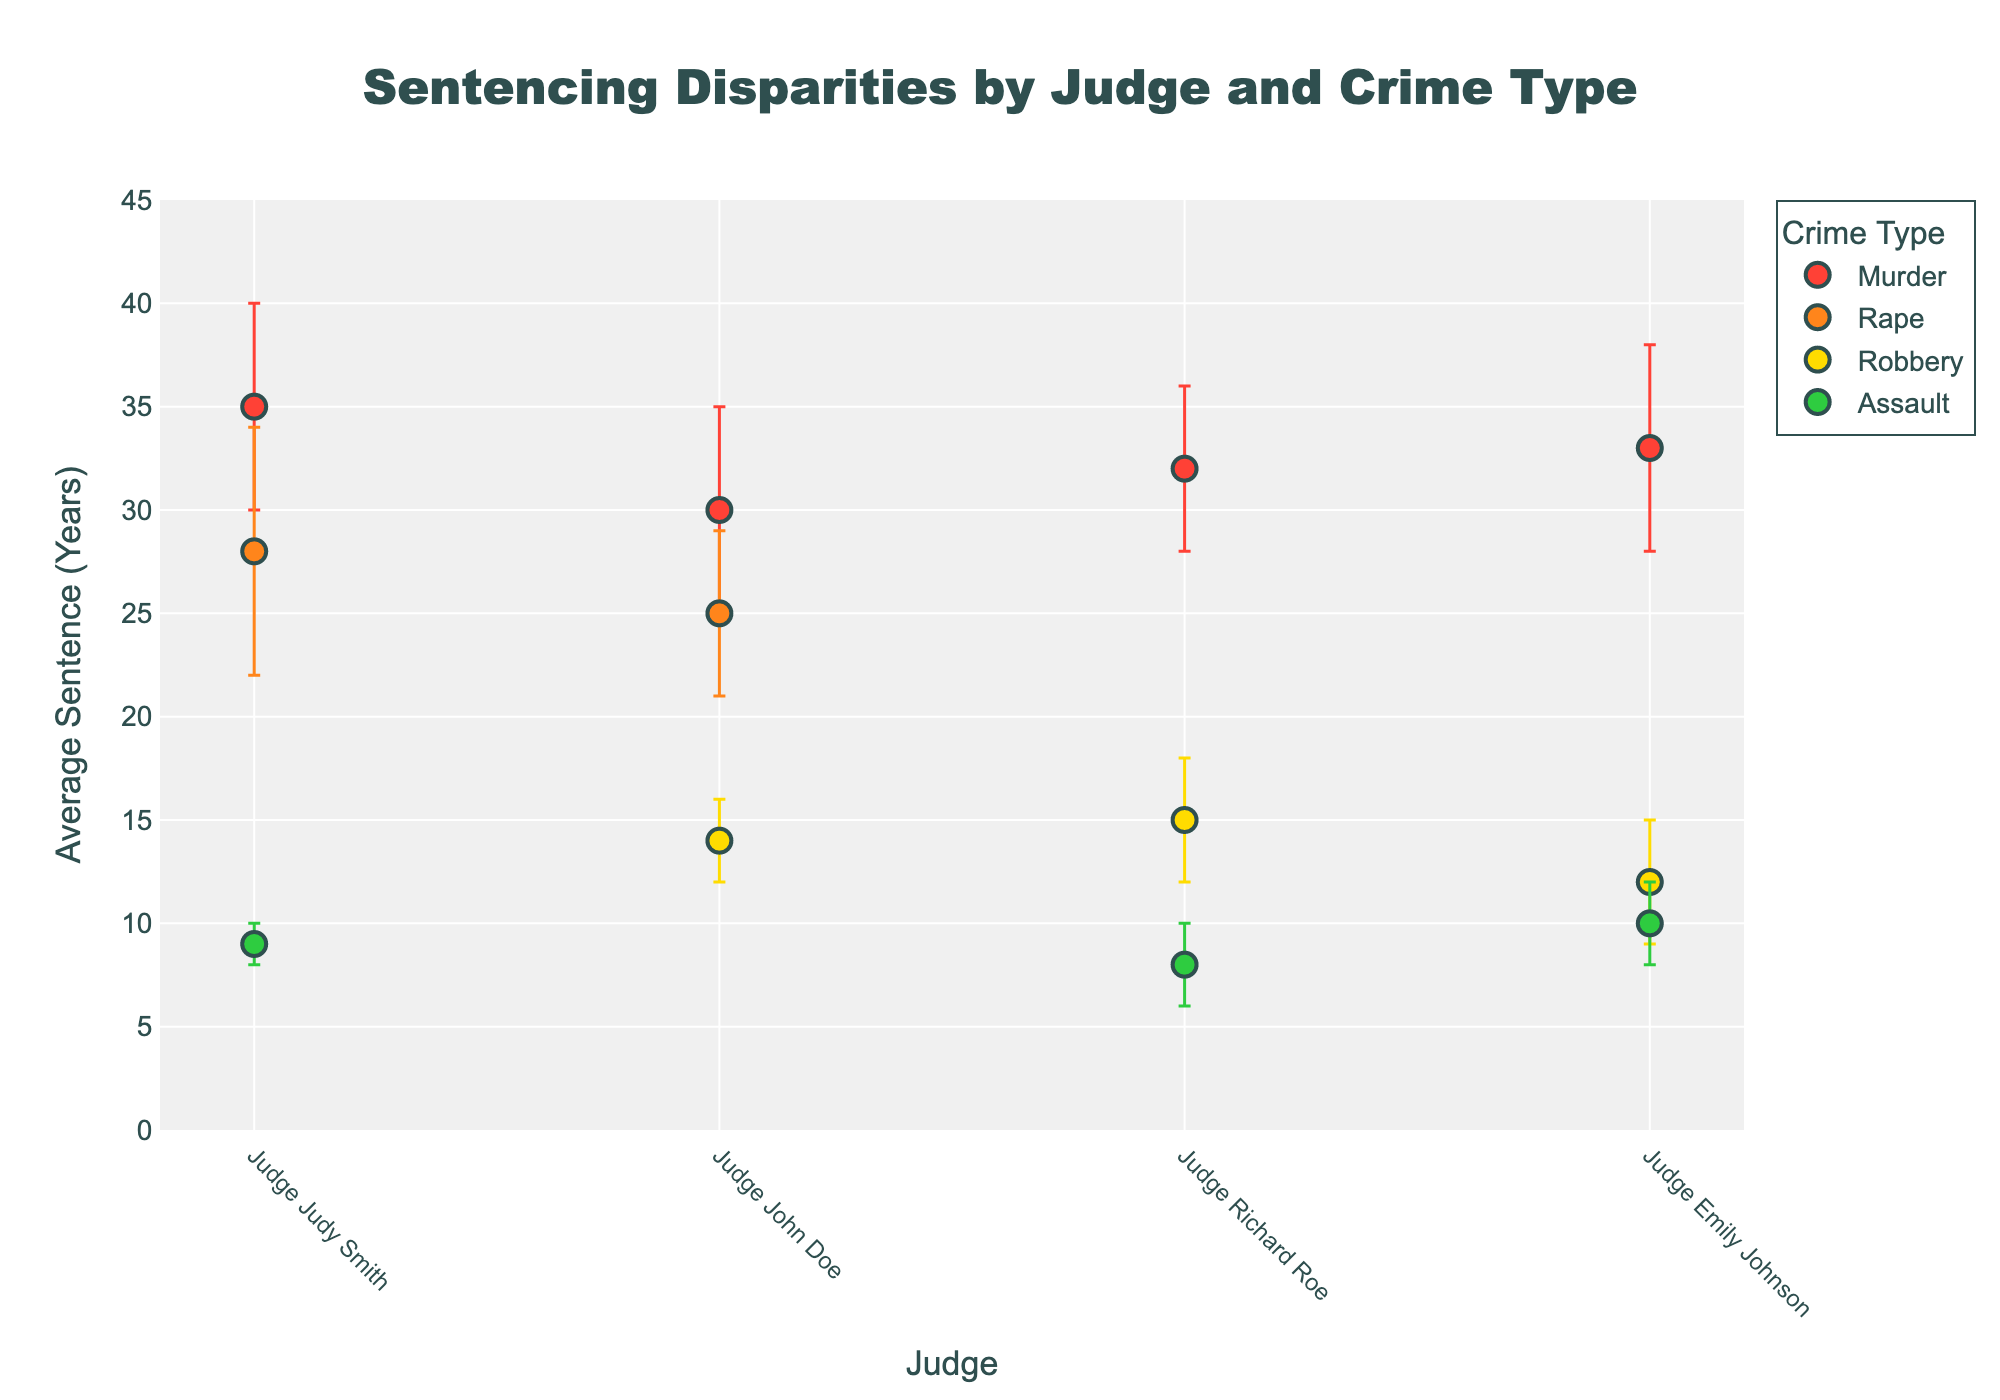Which judge has the highest average sentence for murder? We look at the average sentences for murder and find the judge with the highest value. Judge Emily Johnson has an average sentence of 33 years for murder.
Answer: Judge Emily Johnson What is the range of average sentences for assault cases? Identify the lowest and highest average sentences for assault, then calculate the range. Judge Emily Johnson has the highest at 10 years, and Judge Richard Roe has the lowest at 8 years. The range is 10 - 8 = 2 years.
Answer: 2 years Which crime type has the most consistent sentences across judges, considering the margin of error? Consistency can be inferred from the smallest margins of error. Assault has the smallest margins of error (2 and 1 years), indicating high consistency.
Answer: Assault How does Judge Judy Smith's average sentence for rape compare to Judge John Doe's? Look at the average sentences for rape from these judges: Judge Judy Smith's average is 28 years and Judge John Doe's is 25 years. Compare these two values. Judge Judy Smith gives longer average sentences.
Answer: Judge Judy Smith gives longer sentences What is the total average sentence given by Judge Richard Roe across all crime types? Sum the average sentences by Judge Richard Roe for all crime types: 32 (Murder) + 15 (Robbery) + 8 (Assault) = 55 years.
Answer: 55 years Which judge shows the highest variability in sentencing, and for what crime type? Variability can be assessed by looking at the margin of error. Judge Judy Smith’s margin of error for rape is the highest at 6 years.
Answer: Judge Judy Smith for rape What is the overall trend in sentences for murder among the judges? Average sentences for murder are 35, 30, 32, and 33 years. This shows that all judges give relatively high sentences for murder, all above 30 years.
Answer: High sentences above 30 years across all judges How does the average sentence for robbery given by Judge John Doe compare to the average sentence for robbery given by Judge Richard Roe? Compare the average sentences for robbery for both judges: Judge John Doe gives 14 years and Judge Richard Roe gives 15 years. Judge Richard Roe gives longer sentences.
Answer: Judge Richard Roe gives longer sentences What is the average margin of error across all crime types judged by Judge Emily Johnson? Identify the margin of error for each crime type handled by Judge Emily Johnson and average them: (5 + 5 + 3 + 2)/4 = 15/4 = 3.75 years.
Answer: 3.75 years 